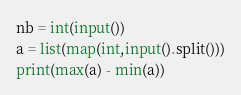<code> <loc_0><loc_0><loc_500><loc_500><_Python_>nb = int(input())
a = list(map(int,input().split()))
print(max(a) - min(a))</code> 